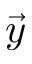<formula> <loc_0><loc_0><loc_500><loc_500>\vec { y }</formula> 